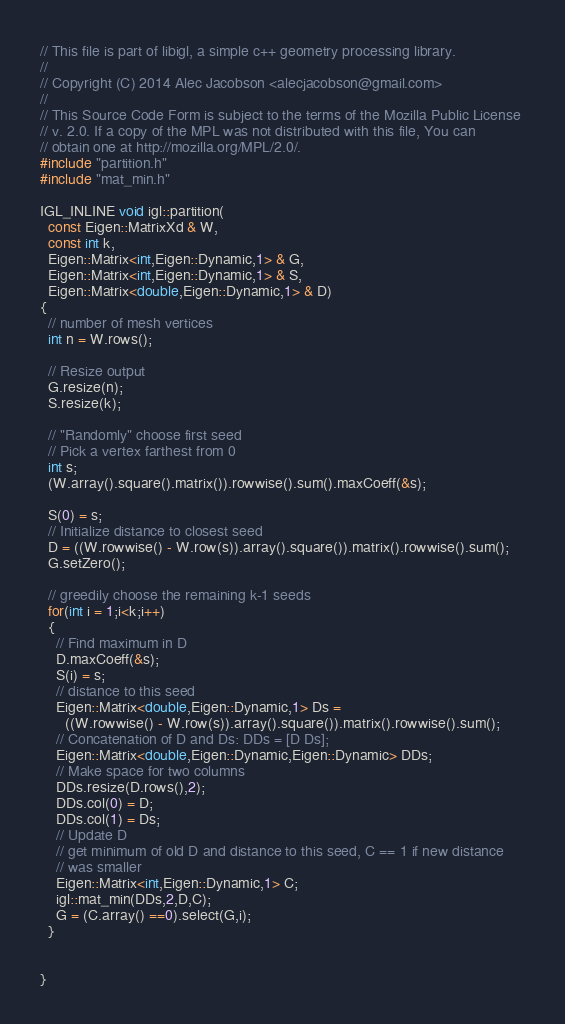<code> <loc_0><loc_0><loc_500><loc_500><_C++_>// This file is part of libigl, a simple c++ geometry processing library.
// 
// Copyright (C) 2014 Alec Jacobson <alecjacobson@gmail.com>
// 
// This Source Code Form is subject to the terms of the Mozilla Public License 
// v. 2.0. If a copy of the MPL was not distributed with this file, You can 
// obtain one at http://mozilla.org/MPL/2.0/.
#include "partition.h"
#include "mat_min.h"

IGL_INLINE void igl::partition(
  const Eigen::MatrixXd & W,
  const int k,
  Eigen::Matrix<int,Eigen::Dynamic,1> & G,
  Eigen::Matrix<int,Eigen::Dynamic,1> & S,
  Eigen::Matrix<double,Eigen::Dynamic,1> & D)
{
  // number of mesh vertices
  int n = W.rows();

  // Resize output
  G.resize(n);
  S.resize(k);

  // "Randomly" choose first seed
  // Pick a vertex farthest from 0
  int s;
  (W.array().square().matrix()).rowwise().sum().maxCoeff(&s);

  S(0) = s;
  // Initialize distance to closest seed
  D = ((W.rowwise() - W.row(s)).array().square()).matrix().rowwise().sum();
  G.setZero();

  // greedily choose the remaining k-1 seeds
  for(int i = 1;i<k;i++)
  {
    // Find maximum in D
    D.maxCoeff(&s);
    S(i) = s;
    // distance to this seed
    Eigen::Matrix<double,Eigen::Dynamic,1> Ds =
      ((W.rowwise() - W.row(s)).array().square()).matrix().rowwise().sum();
    // Concatenation of D and Ds: DDs = [D Ds];
    Eigen::Matrix<double,Eigen::Dynamic,Eigen::Dynamic> DDs;
    // Make space for two columns
    DDs.resize(D.rows(),2);
    DDs.col(0) = D;
    DDs.col(1) = Ds;
    // Update D
    // get minimum of old D and distance to this seed, C == 1 if new distance
    // was smaller
    Eigen::Matrix<int,Eigen::Dynamic,1> C;
    igl::mat_min(DDs,2,D,C);
    G = (C.array() ==0).select(G,i);
  }


}
</code> 